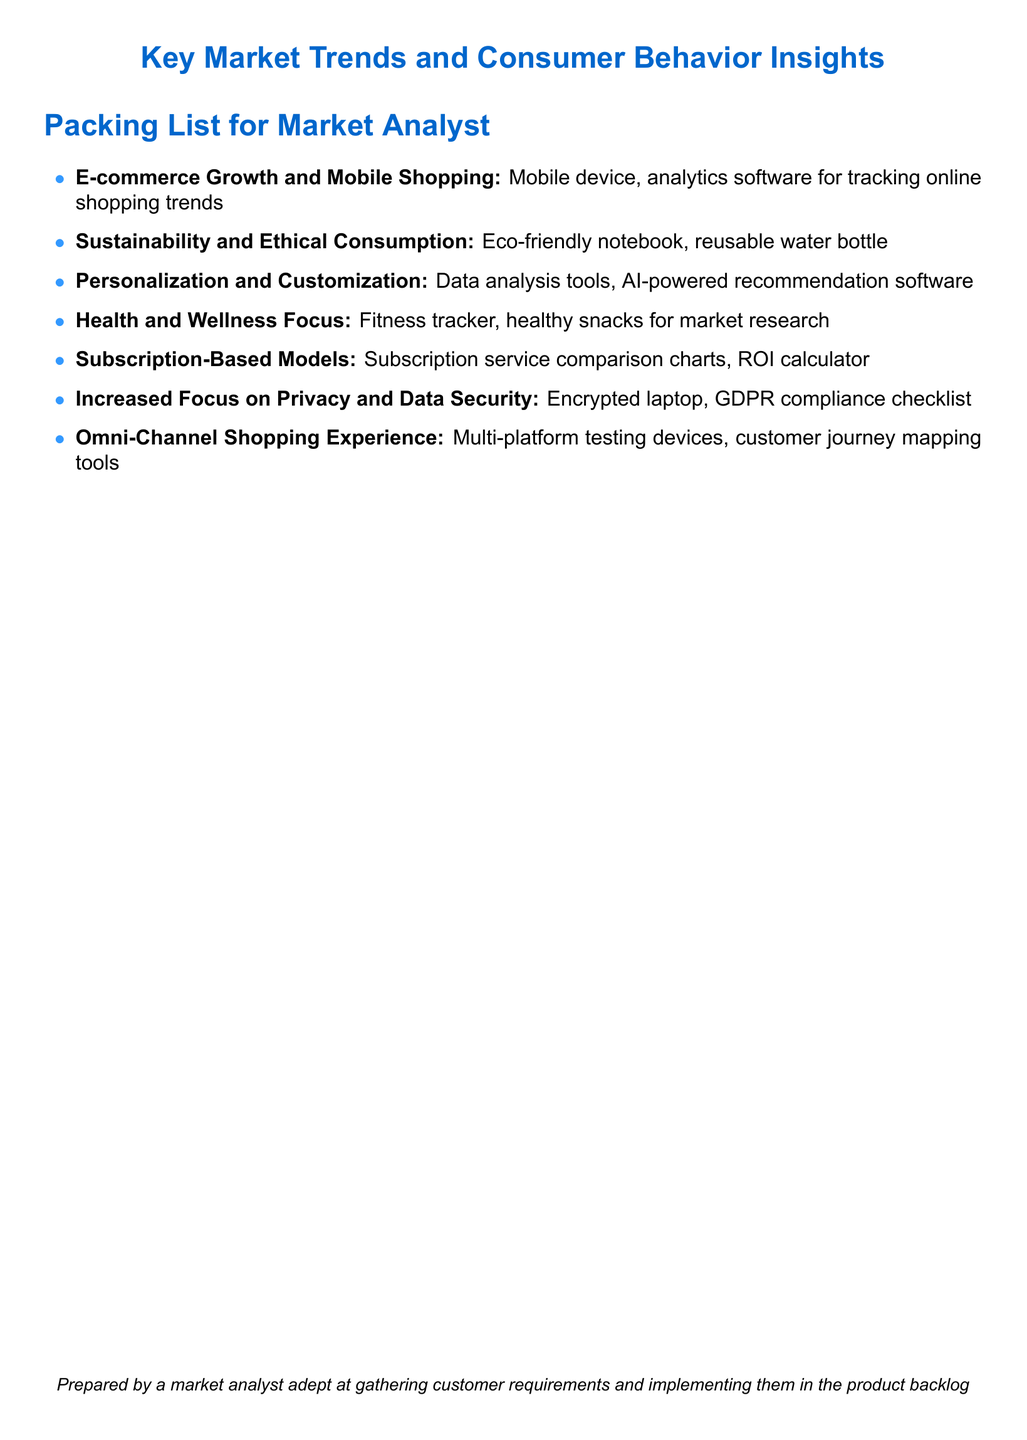What is the first key market trend listed? The first key market trend is the one mentioned at the start of the itemized list in the document.
Answer: E-commerce Growth and Mobile Shopping What item is associated with sustainability and ethical consumption? The document lists specific items for each market trend, and sustainability focuses on eco-friendly products.
Answer: Eco-friendly notebook How many key market trends are mentioned in total? The number of key market trends can be counted based on the bullet points in the list.
Answer: 7 What tool is suggested for personalization and customization? This tool is indicated as a necessity under the personalization and customization trend.
Answer: AI-powered recommendation software What item is recommended for health and wellness focus? The recommended item under the health and wellness focus is mentioned as participation in fitness-related activities.
Answer: Fitness tracker Which aspect of the market is tied to an encrypted laptop? The encrypted laptop is associated with an increasing concern stated in the document regarding individual privacy.
Answer: Increased Focus on Privacy and Data Security What type of model is highlighted in the packing list? The packing list references a specific type of business model that has gained popularity.
Answer: Subscription-Based Models What is one tool mentioned for omni-channel shopping experience? The document indicates specific tools needed for mapping the customer journey.
Answer: Customer journey mapping tools 